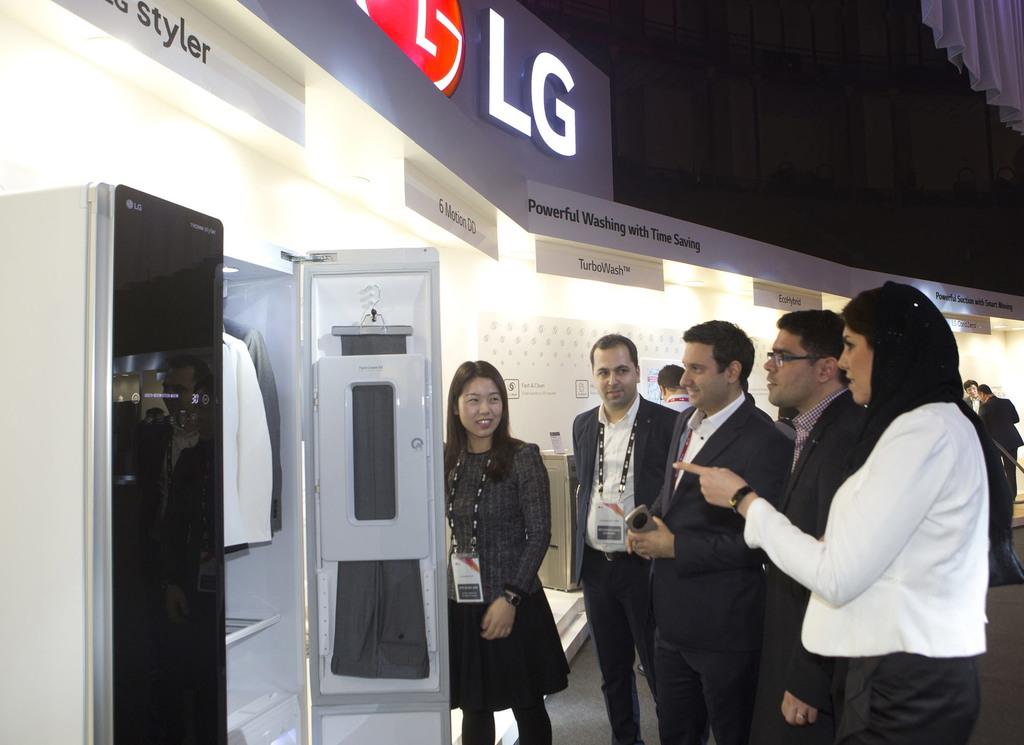What kind of printer is this?
Make the answer very short. Lg. What is the name of the company at the top?
Your answer should be compact. Lg. 